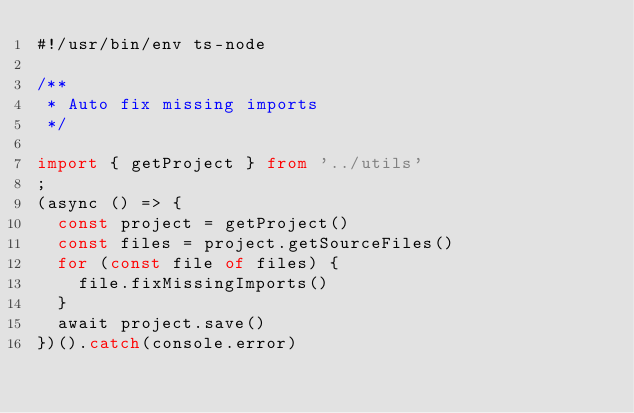Convert code to text. <code><loc_0><loc_0><loc_500><loc_500><_TypeScript_>#!/usr/bin/env ts-node

/**
 * Auto fix missing imports
 */

import { getProject } from '../utils'
;
(async () => {
  const project = getProject()
  const files = project.getSourceFiles()
  for (const file of files) {
    file.fixMissingImports()
  }
  await project.save()
})().catch(console.error)
</code> 